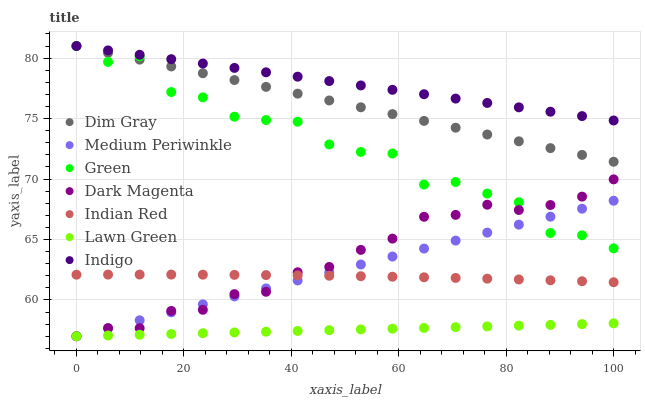Does Lawn Green have the minimum area under the curve?
Answer yes or no. Yes. Does Indigo have the maximum area under the curve?
Answer yes or no. Yes. Does Dim Gray have the minimum area under the curve?
Answer yes or no. No. Does Dim Gray have the maximum area under the curve?
Answer yes or no. No. Is Lawn Green the smoothest?
Answer yes or no. Yes. Is Green the roughest?
Answer yes or no. Yes. Is Dim Gray the smoothest?
Answer yes or no. No. Is Dim Gray the roughest?
Answer yes or no. No. Does Lawn Green have the lowest value?
Answer yes or no. Yes. Does Dim Gray have the lowest value?
Answer yes or no. No. Does Green have the highest value?
Answer yes or no. Yes. Does Dark Magenta have the highest value?
Answer yes or no. No. Is Lawn Green less than Indian Red?
Answer yes or no. Yes. Is Indian Red greater than Lawn Green?
Answer yes or no. Yes. Does Green intersect Indigo?
Answer yes or no. Yes. Is Green less than Indigo?
Answer yes or no. No. Is Green greater than Indigo?
Answer yes or no. No. Does Lawn Green intersect Indian Red?
Answer yes or no. No. 